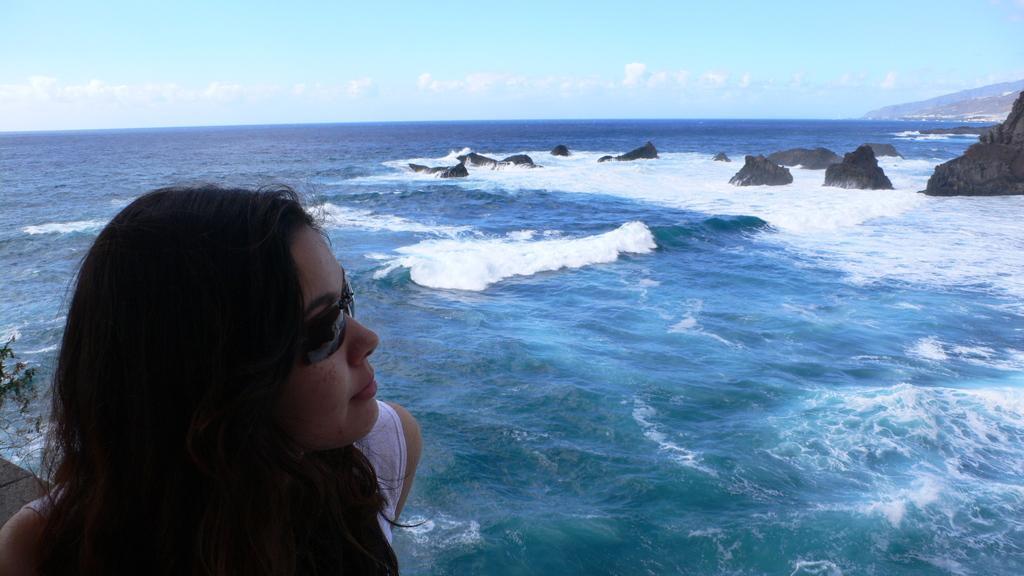In one or two sentences, can you explain what this image depicts? A beautiful woman is there in the left side, this is water in the middle. In the right side there are stones. 